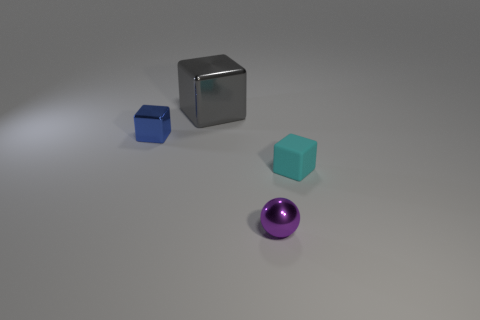Add 2 green metal objects. How many objects exist? 6 Subtract all balls. How many objects are left? 3 Subtract 0 purple cubes. How many objects are left? 4 Subtract all small brown shiny blocks. Subtract all tiny purple metal balls. How many objects are left? 3 Add 1 tiny blocks. How many tiny blocks are left? 3 Add 1 big green rubber cylinders. How many big green rubber cylinders exist? 1 